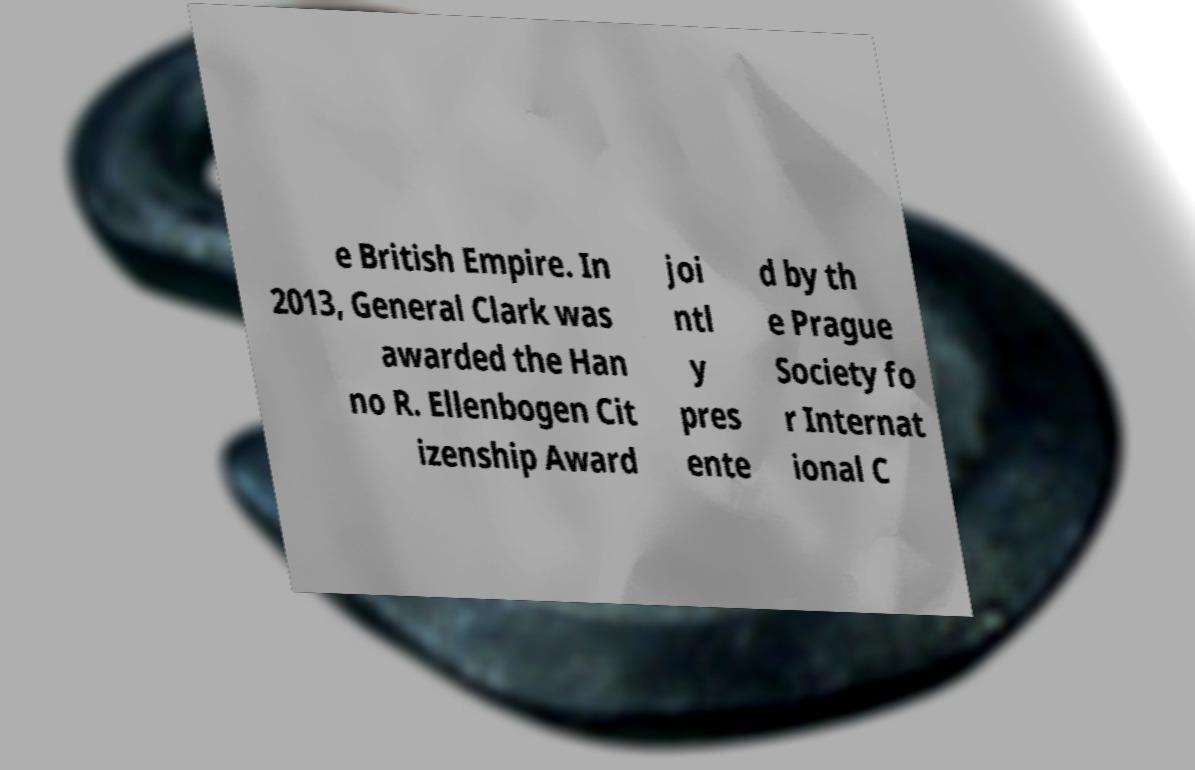What messages or text are displayed in this image? I need them in a readable, typed format. e British Empire. In 2013, General Clark was awarded the Han no R. Ellenbogen Cit izenship Award joi ntl y pres ente d by th e Prague Society fo r Internat ional C 